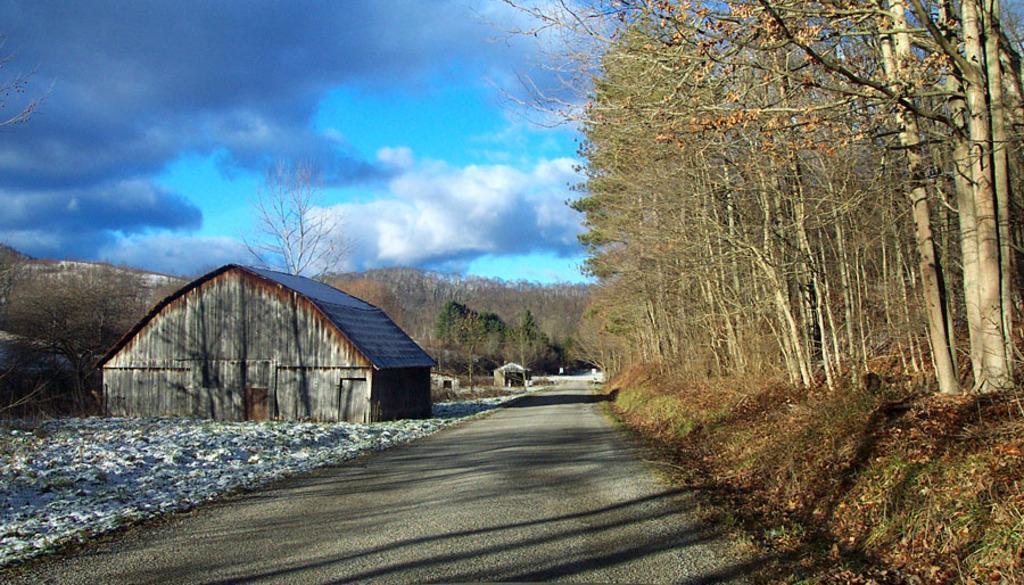Could you give a brief overview of what you see in this image? In this picture there are houses and there are trees. At the back there is a mountain. At the top there is sky and there are clouds. At the bottom there is a road and there are dried leaves and there might be snow. 